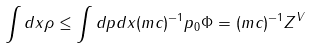Convert formula to latex. <formula><loc_0><loc_0><loc_500><loc_500>\int d { x } \rho \leq \int d { p } d { x } ( m c ) ^ { - 1 } p _ { 0 } \Phi = ( m c ) ^ { - 1 } Z ^ { V }</formula> 